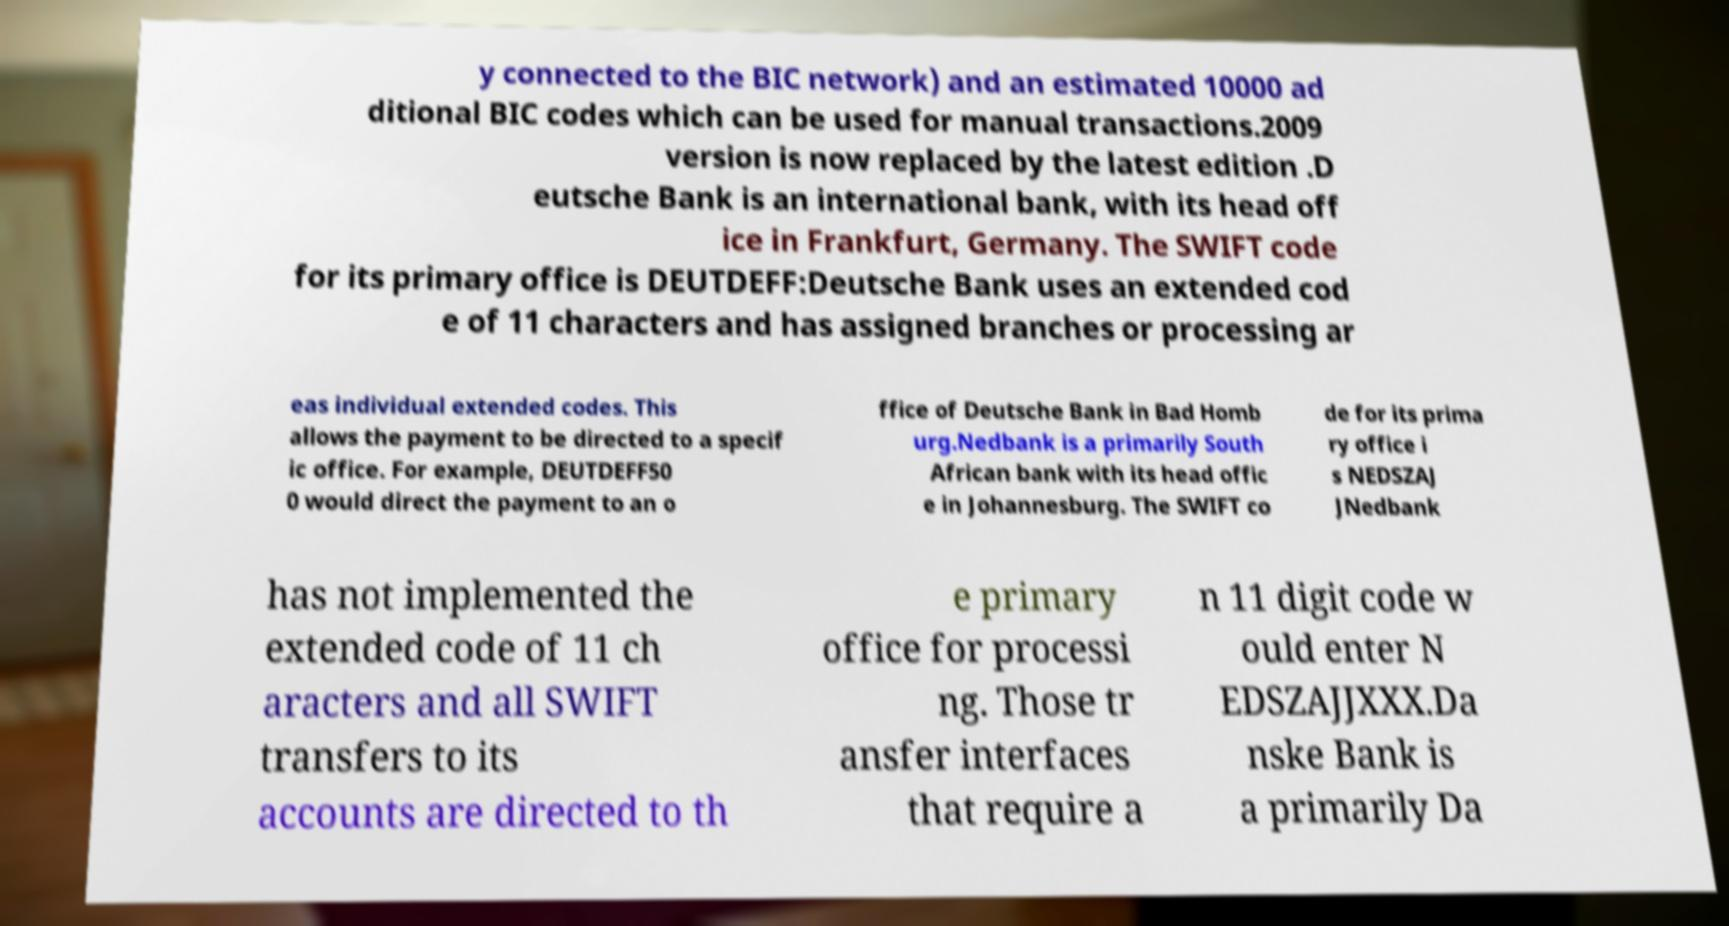Could you extract and type out the text from this image? y connected to the BIC network) and an estimated 10000 ad ditional BIC codes which can be used for manual transactions.2009 version is now replaced by the latest edition .D eutsche Bank is an international bank, with its head off ice in Frankfurt, Germany. The SWIFT code for its primary office is DEUTDEFF:Deutsche Bank uses an extended cod e of 11 characters and has assigned branches or processing ar eas individual extended codes. This allows the payment to be directed to a specif ic office. For example, DEUTDEFF50 0 would direct the payment to an o ffice of Deutsche Bank in Bad Homb urg.Nedbank is a primarily South African bank with its head offic e in Johannesburg. The SWIFT co de for its prima ry office i s NEDSZAJ JNedbank has not implemented the extended code of 11 ch aracters and all SWIFT transfers to its accounts are directed to th e primary office for processi ng. Those tr ansfer interfaces that require a n 11 digit code w ould enter N EDSZAJJXXX.Da nske Bank is a primarily Da 